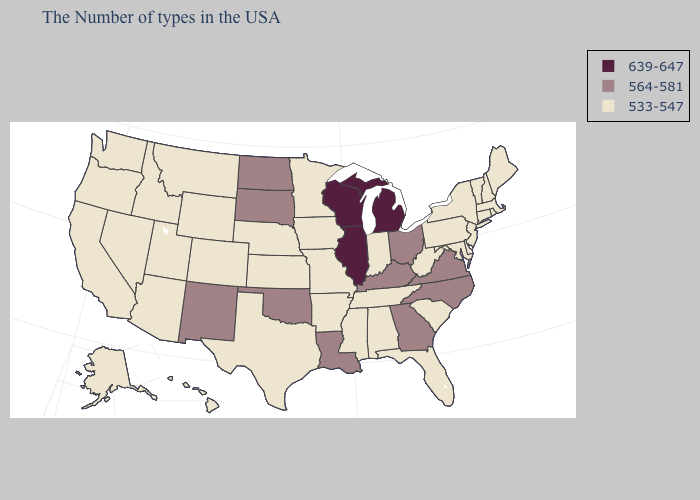What is the highest value in the West ?
Short answer required. 564-581. Name the states that have a value in the range 533-547?
Keep it brief. Maine, Massachusetts, Rhode Island, New Hampshire, Vermont, Connecticut, New York, New Jersey, Delaware, Maryland, Pennsylvania, South Carolina, West Virginia, Florida, Indiana, Alabama, Tennessee, Mississippi, Missouri, Arkansas, Minnesota, Iowa, Kansas, Nebraska, Texas, Wyoming, Colorado, Utah, Montana, Arizona, Idaho, Nevada, California, Washington, Oregon, Alaska, Hawaii. Name the states that have a value in the range 533-547?
Give a very brief answer. Maine, Massachusetts, Rhode Island, New Hampshire, Vermont, Connecticut, New York, New Jersey, Delaware, Maryland, Pennsylvania, South Carolina, West Virginia, Florida, Indiana, Alabama, Tennessee, Mississippi, Missouri, Arkansas, Minnesota, Iowa, Kansas, Nebraska, Texas, Wyoming, Colorado, Utah, Montana, Arizona, Idaho, Nevada, California, Washington, Oregon, Alaska, Hawaii. Among the states that border Mississippi , which have the highest value?
Be succinct. Louisiana. Name the states that have a value in the range 533-547?
Keep it brief. Maine, Massachusetts, Rhode Island, New Hampshire, Vermont, Connecticut, New York, New Jersey, Delaware, Maryland, Pennsylvania, South Carolina, West Virginia, Florida, Indiana, Alabama, Tennessee, Mississippi, Missouri, Arkansas, Minnesota, Iowa, Kansas, Nebraska, Texas, Wyoming, Colorado, Utah, Montana, Arizona, Idaho, Nevada, California, Washington, Oregon, Alaska, Hawaii. Name the states that have a value in the range 564-581?
Keep it brief. Virginia, North Carolina, Ohio, Georgia, Kentucky, Louisiana, Oklahoma, South Dakota, North Dakota, New Mexico. Which states have the lowest value in the MidWest?
Answer briefly. Indiana, Missouri, Minnesota, Iowa, Kansas, Nebraska. How many symbols are there in the legend?
Keep it brief. 3. What is the value of Arkansas?
Keep it brief. 533-547. Name the states that have a value in the range 533-547?
Answer briefly. Maine, Massachusetts, Rhode Island, New Hampshire, Vermont, Connecticut, New York, New Jersey, Delaware, Maryland, Pennsylvania, South Carolina, West Virginia, Florida, Indiana, Alabama, Tennessee, Mississippi, Missouri, Arkansas, Minnesota, Iowa, Kansas, Nebraska, Texas, Wyoming, Colorado, Utah, Montana, Arizona, Idaho, Nevada, California, Washington, Oregon, Alaska, Hawaii. Does Iowa have the same value as Illinois?
Quick response, please. No. Which states have the lowest value in the MidWest?
Short answer required. Indiana, Missouri, Minnesota, Iowa, Kansas, Nebraska. Is the legend a continuous bar?
Give a very brief answer. No. What is the value of South Dakota?
Give a very brief answer. 564-581. How many symbols are there in the legend?
Be succinct. 3. 